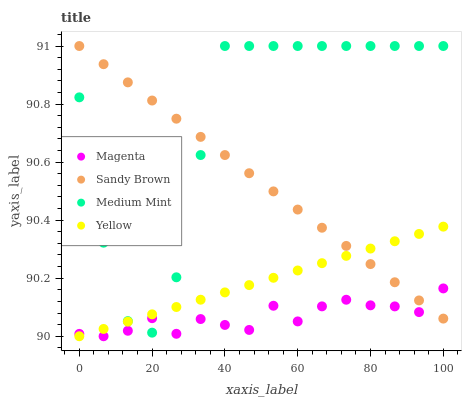Does Magenta have the minimum area under the curve?
Answer yes or no. Yes. Does Medium Mint have the maximum area under the curve?
Answer yes or no. Yes. Does Sandy Brown have the minimum area under the curve?
Answer yes or no. No. Does Sandy Brown have the maximum area under the curve?
Answer yes or no. No. Is Yellow the smoothest?
Answer yes or no. Yes. Is Medium Mint the roughest?
Answer yes or no. Yes. Is Magenta the smoothest?
Answer yes or no. No. Is Magenta the roughest?
Answer yes or no. No. Does Magenta have the lowest value?
Answer yes or no. Yes. Does Sandy Brown have the lowest value?
Answer yes or no. No. Does Sandy Brown have the highest value?
Answer yes or no. Yes. Does Magenta have the highest value?
Answer yes or no. No. Does Sandy Brown intersect Yellow?
Answer yes or no. Yes. Is Sandy Brown less than Yellow?
Answer yes or no. No. Is Sandy Brown greater than Yellow?
Answer yes or no. No. 